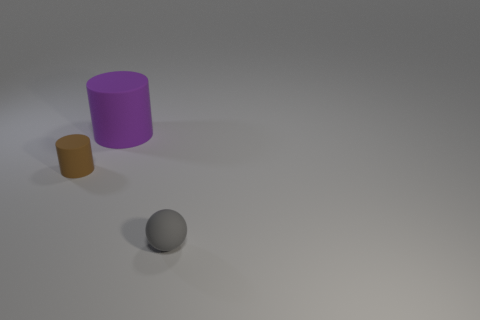Add 3 large purple cylinders. How many objects exist? 6 Subtract all cylinders. How many objects are left? 1 Subtract all tiny rubber objects. Subtract all large purple matte things. How many objects are left? 0 Add 3 small brown things. How many small brown things are left? 4 Add 3 brown metal things. How many brown metal things exist? 3 Subtract 0 yellow balls. How many objects are left? 3 